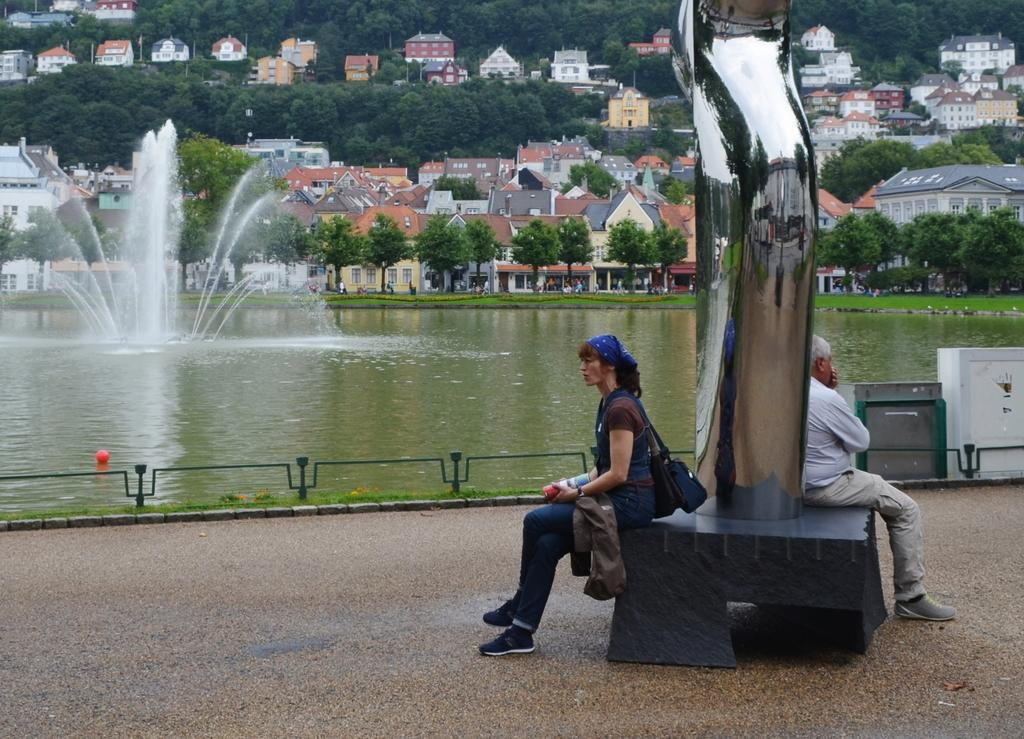How many people are sitting in the image? There are two people sitting in the image. What can be seen besides the people in the image? There is a sculpture, a fountain, water, trees, and sheds in the image. What is the natural element present in the image? Trees are present in the background of the image. What architectural feature can be seen in the image? There are sheds in the background of the image. What is the name of the thing that the people are sitting on in the image? The provided facts do not mention the name of the object the people are sitting on, so it cannot be determined from the image. 